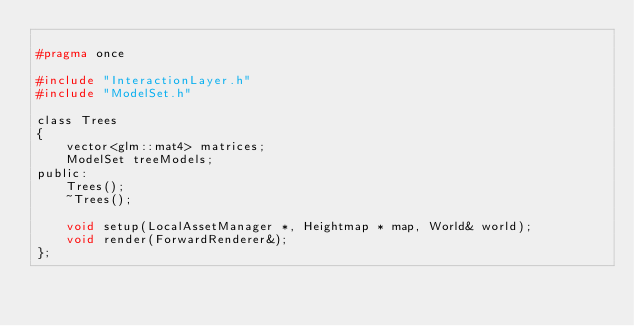<code> <loc_0><loc_0><loc_500><loc_500><_C_>
#pragma once

#include "InteractionLayer.h"
#include "ModelSet.h"

class Trees
{
    vector<glm::mat4> matrices;
    ModelSet treeModels;
public:
    Trees();
    ~Trees();

    void setup(LocalAssetManager *, Heightmap * map, World& world);
    void render(ForwardRenderer&);
};</code> 